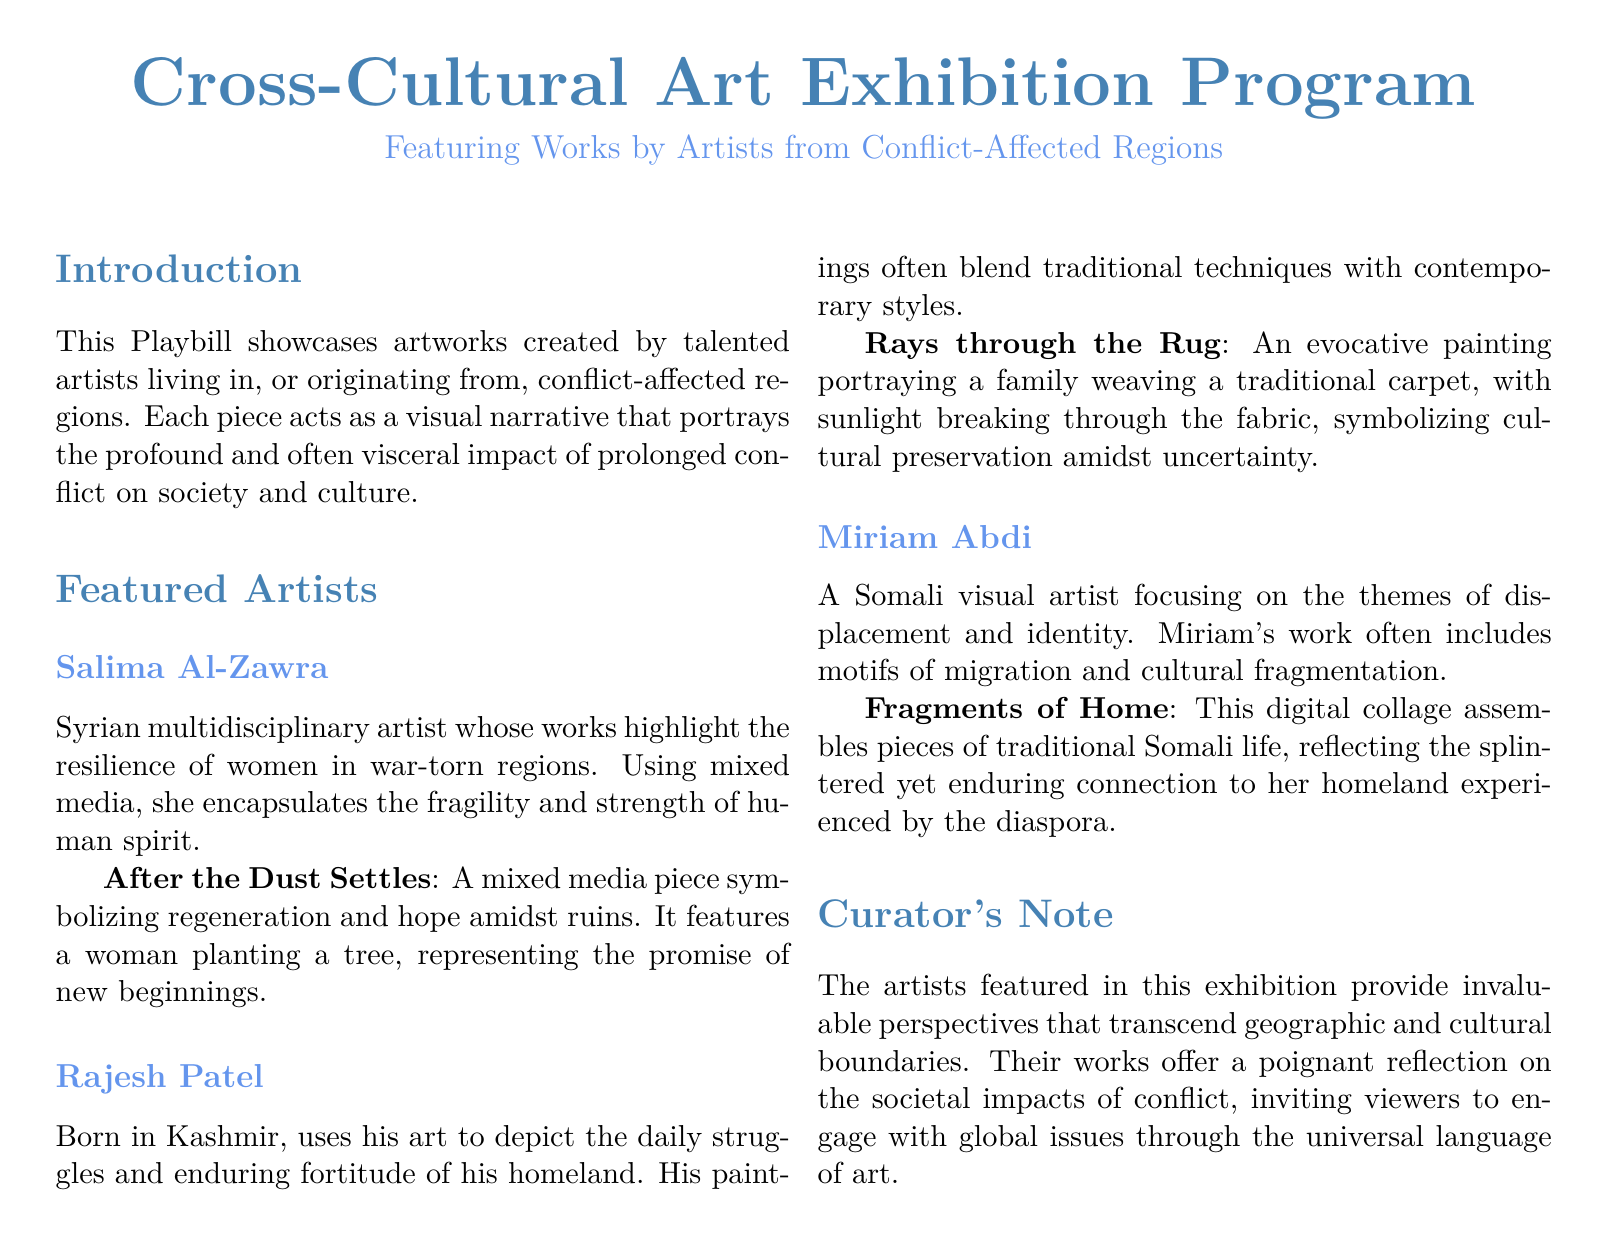What is the title of the exhibition program? The title of the exhibition program is presented at the top of the document, specifically highlighted in large font.
Answer: Cross-Cultural Art Exhibition Program Who is the artist from Syria? The artist from Syria is mentioned in the "Featured Artists" section of the document.
Answer: Salima Al-Zawra What does the artwork "Rays through the Rug" symbolize? The symbolism of the artwork is explained in context with its description, focusing on cultural preservation.
Answer: Cultural preservation How many featured artists are listed in the document? The document lists artists in the "Featured Artists" section, and the total is counted from the mentioned entries.
Answer: Three What is the medium used by Rajesh Patel? The medium used by Rajesh Patel is specified in his artist bio in the Playbill.
Answer: Painting What themes does Miriam Abdi focus on in her work? The themes are described in the overview of Miriam's art, providing insight into her focus areas.
Answer: Displacement and identity What does the curator's note emphasize? The curator's note summarizes the intent and impact of the artworks within the exhibition.
Answer: Perspectives that transcend geographic and cultural boundaries What type of art does Salima Al-Zawra primarily create? The document specifies Salima Al-Zawra's artistic approach within her biography in the exhibition.
Answer: Multidisciplinary art What visual narrative does "After the Dust Settles" represent? The description of the artwork directly outlines the narrative it embodies, focusing on regeneration.
Answer: Regeneration and hope 